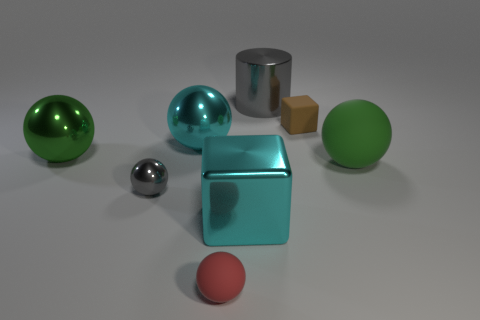Subtract all small red spheres. How many spheres are left? 4 Subtract all cyan blocks. How many blocks are left? 1 Subtract all balls. How many objects are left? 3 Subtract 1 cylinders. How many cylinders are left? 0 Subtract all blue spheres. How many purple cylinders are left? 0 Subtract all gray metal balls. Subtract all gray spheres. How many objects are left? 6 Add 3 tiny red rubber spheres. How many tiny red rubber spheres are left? 4 Add 3 small rubber balls. How many small rubber balls exist? 4 Add 2 cyan matte blocks. How many objects exist? 10 Subtract 0 yellow spheres. How many objects are left? 8 